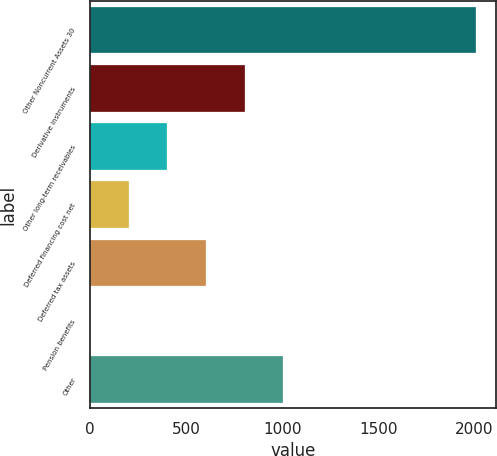<chart> <loc_0><loc_0><loc_500><loc_500><bar_chart><fcel>Other Noncurrent Assets 30<fcel>Derivative instruments<fcel>Other long-term receivables<fcel>Deferred financing cost net<fcel>Deferred tax assets<fcel>Pension benefits<fcel>Other<nl><fcel>2012<fcel>805.34<fcel>403.12<fcel>202.01<fcel>604.23<fcel>0.9<fcel>1006.45<nl></chart> 